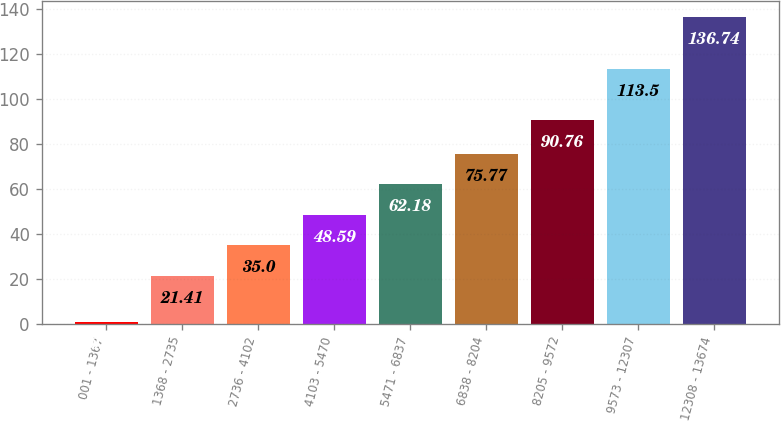Convert chart to OTSL. <chart><loc_0><loc_0><loc_500><loc_500><bar_chart><fcel>001 - 1367<fcel>1368 - 2735<fcel>2736 - 4102<fcel>4103 - 5470<fcel>5471 - 6837<fcel>6838 - 8204<fcel>8205 - 9572<fcel>9573 - 12307<fcel>12308 - 13674<nl><fcel>0.84<fcel>21.41<fcel>35<fcel>48.59<fcel>62.18<fcel>75.77<fcel>90.76<fcel>113.5<fcel>136.74<nl></chart> 